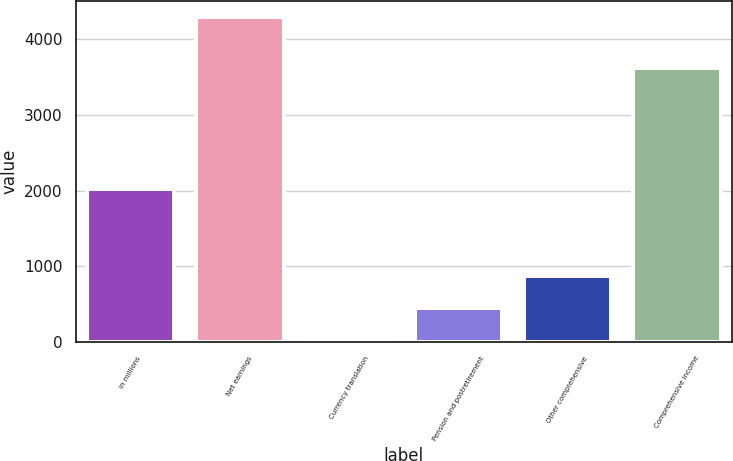Convert chart. <chart><loc_0><loc_0><loc_500><loc_500><bar_chart><fcel>in millions<fcel>Net earnings<fcel>Currency translation<fcel>Pension and postretirement<fcel>Other comprehensive<fcel>Comprehensive income<nl><fcel>2017<fcel>4286<fcel>22<fcel>448.4<fcel>874.8<fcel>3622<nl></chart> 